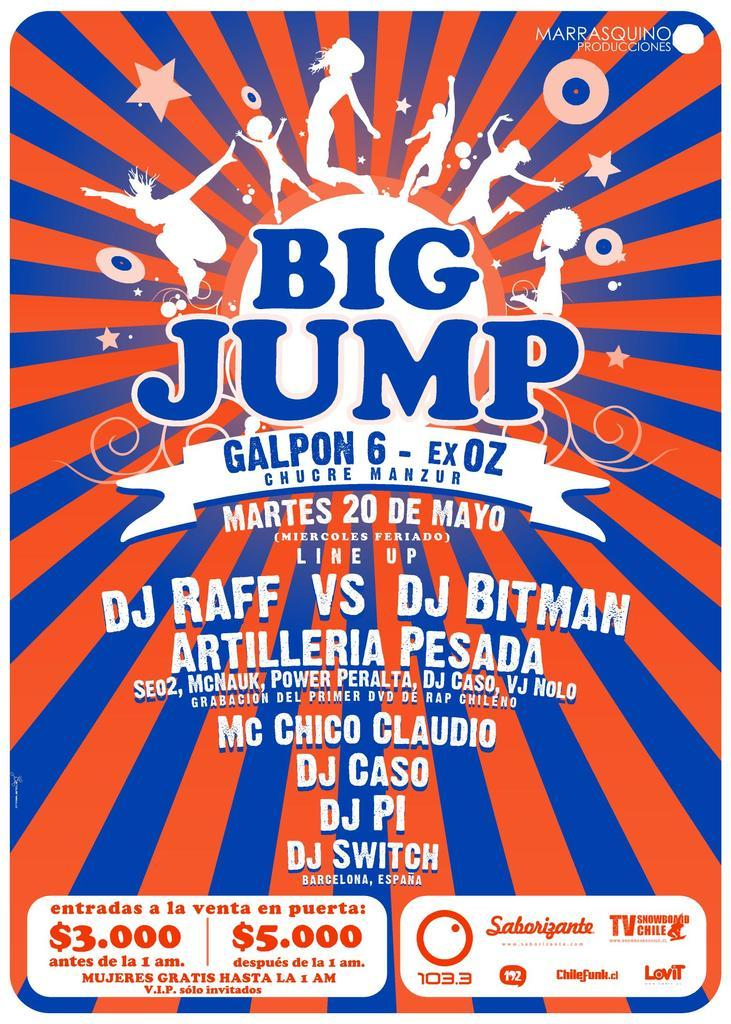<image>
Share a concise interpretation of the image provided. An ad for Big Jump has Spanish words in all but the title. 